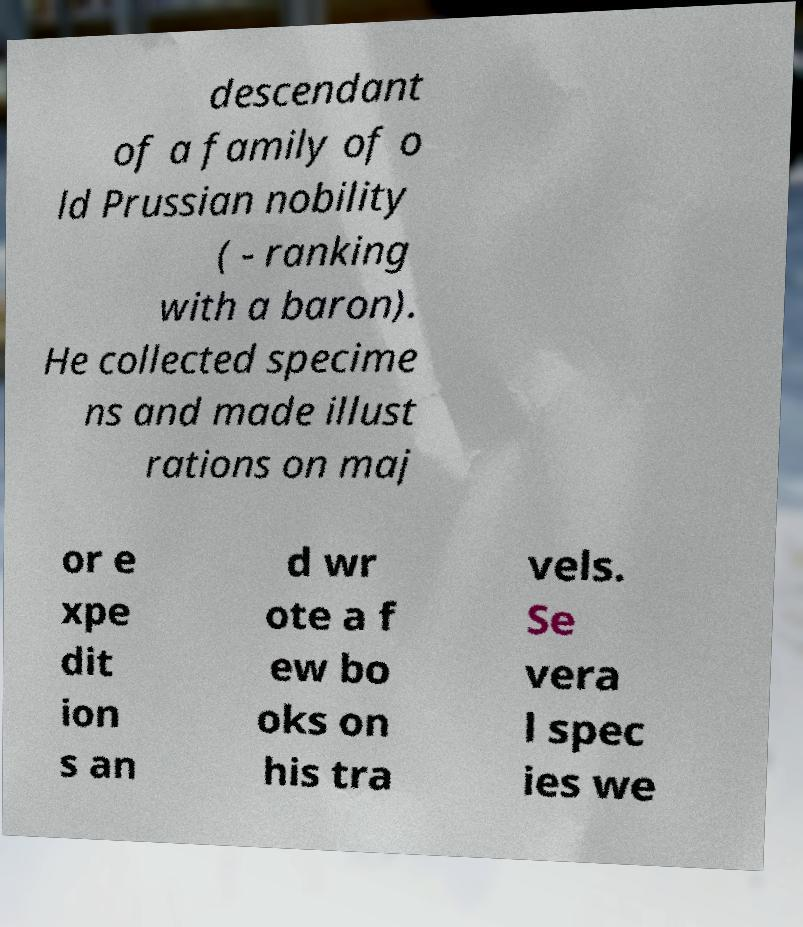For documentation purposes, I need the text within this image transcribed. Could you provide that? descendant of a family of o ld Prussian nobility ( - ranking with a baron). He collected specime ns and made illust rations on maj or e xpe dit ion s an d wr ote a f ew bo oks on his tra vels. Se vera l spec ies we 